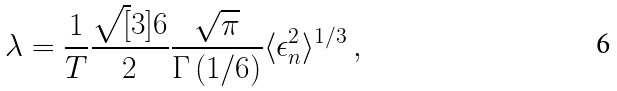Convert formula to latex. <formula><loc_0><loc_0><loc_500><loc_500>\lambda = \frac { 1 } { T } \frac { \sqrt { [ } 3 ] { 6 } } { 2 } \frac { \sqrt { \pi } } { \Gamma \left ( 1 / 6 \right ) } \langle \epsilon _ { n } ^ { 2 } \rangle ^ { 1 / 3 } \, ,</formula> 